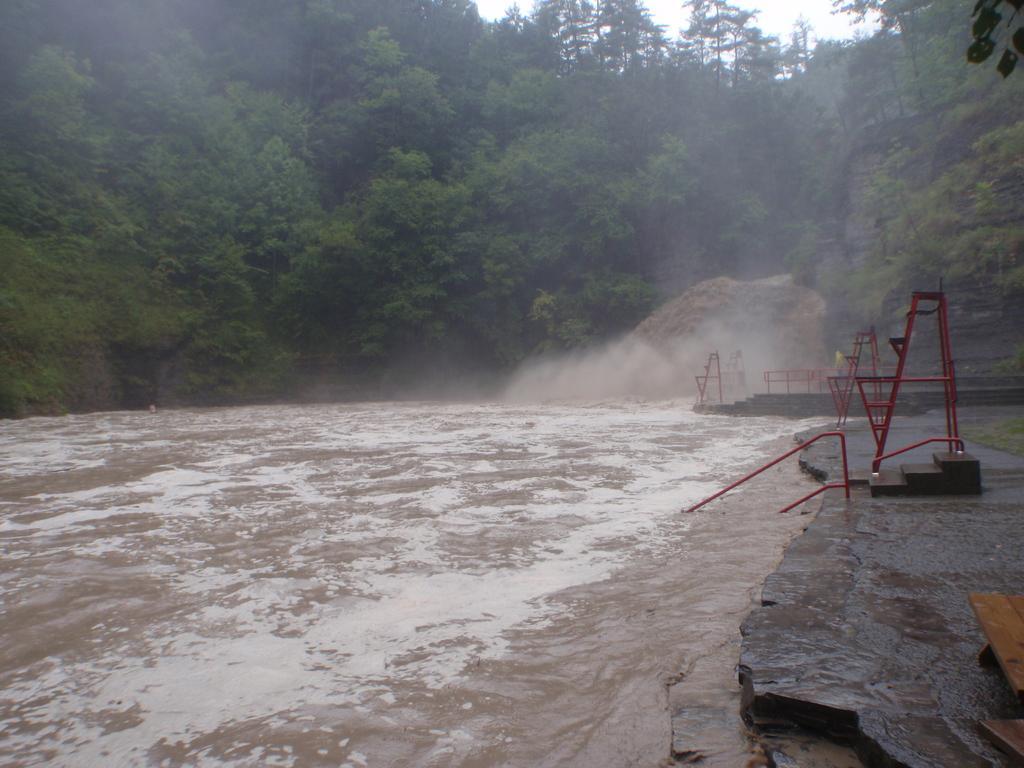In one or two sentences, can you explain what this image depicts? In this image I can see the lake and I can see red color stands and stones and wooden objects visible on right side , on the right side ,at the top I can see the sky and trees. 